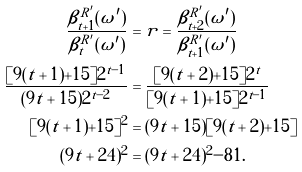Convert formula to latex. <formula><loc_0><loc_0><loc_500><loc_500>\frac { \beta ^ { R ^ { \prime } } _ { t + 1 } ( \omega ^ { \prime } ) } { \beta ^ { R ^ { \prime } } _ { t } ( \omega ^ { \prime } ) } & = r = \frac { \beta ^ { R ^ { \prime } } _ { t + 2 } ( \omega ^ { \prime } ) } { \beta ^ { R ^ { \prime } } _ { t + 1 } ( \omega ^ { \prime } ) } \\ \frac { [ 9 ( t + 1 ) + 1 5 ] 2 ^ { t - 1 } } { ( 9 t + 1 5 ) 2 ^ { t - 2 } } & = \frac { [ 9 ( t + 2 ) + 1 5 ] 2 ^ { t } } { [ 9 ( t + 1 ) + 1 5 ] 2 ^ { t - 1 } } \\ [ 9 ( t + 1 ) + 1 5 ] ^ { 2 } & = ( 9 t + 1 5 ) [ 9 ( t + 2 ) + 1 5 ] \\ ( 9 t + 2 4 ) ^ { 2 } & = ( 9 t + 2 4 ) ^ { 2 } - 8 1 .</formula> 